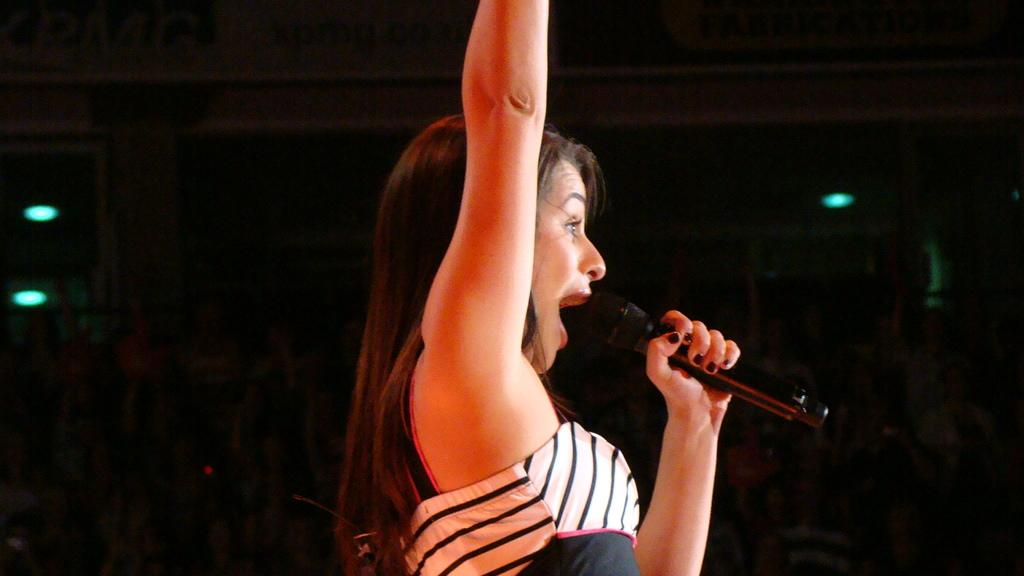Who is the main subject in the image? There is a woman in the image. What is the woman doing in the image? The woman is catching a microphone. Can you describe any additional features in the image? There may be lights present on the roof, although this fact is less certain. What color is the son's shirt in the image? There is no son present in the image, only the woman catching a microphone. 